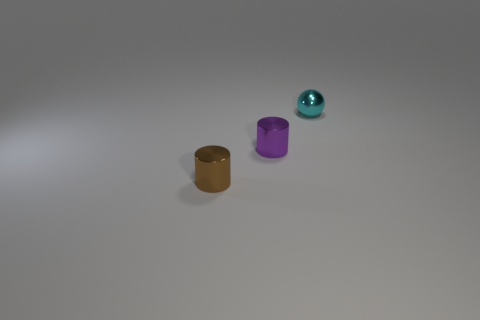What number of objects are either tiny purple rubber cylinders or brown objects?
Offer a terse response. 1. There is a ball that is made of the same material as the small purple cylinder; what is its color?
Your response must be concise. Cyan. There is a small object in front of the purple cylinder; is it the same shape as the purple thing?
Provide a short and direct response. Yes. How many things are metallic things that are in front of the small cyan ball or cyan metallic balls that are behind the brown cylinder?
Give a very brief answer. 3. The other shiny object that is the same shape as the purple shiny object is what color?
Ensure brevity in your answer.  Brown. Is there any other thing that is the same shape as the tiny cyan metal thing?
Your answer should be compact. No. There is a brown metallic object; is its shape the same as the small purple metal thing that is right of the tiny brown cylinder?
Your response must be concise. Yes. What is the material of the tiny brown thing?
Provide a short and direct response. Metal. How many other objects are the same material as the brown cylinder?
Offer a very short reply. 2. Are there fewer tiny metallic balls left of the shiny sphere than tiny metal cylinders that are on the left side of the tiny purple shiny thing?
Ensure brevity in your answer.  Yes. 